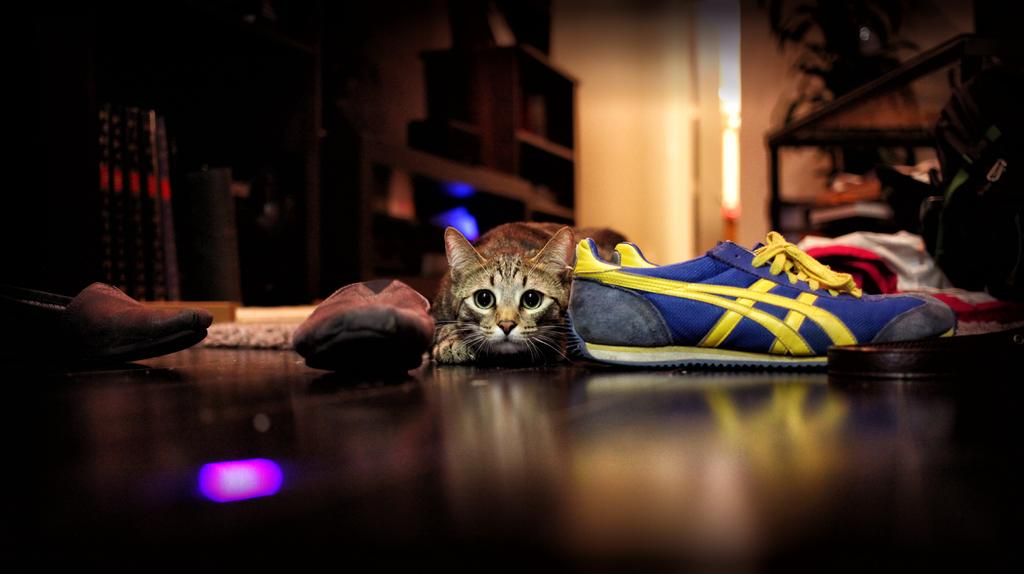What type of animal can be seen in the image? There is a cat in the image. What other items are visible in the image? There are shoes and other objects in the image. Can you describe the background of the image? There are lights in the background of the image. How many eyes does the needle have in the image? There is no needle present in the image, so it is not possible to determine the number of eyes it might have. 